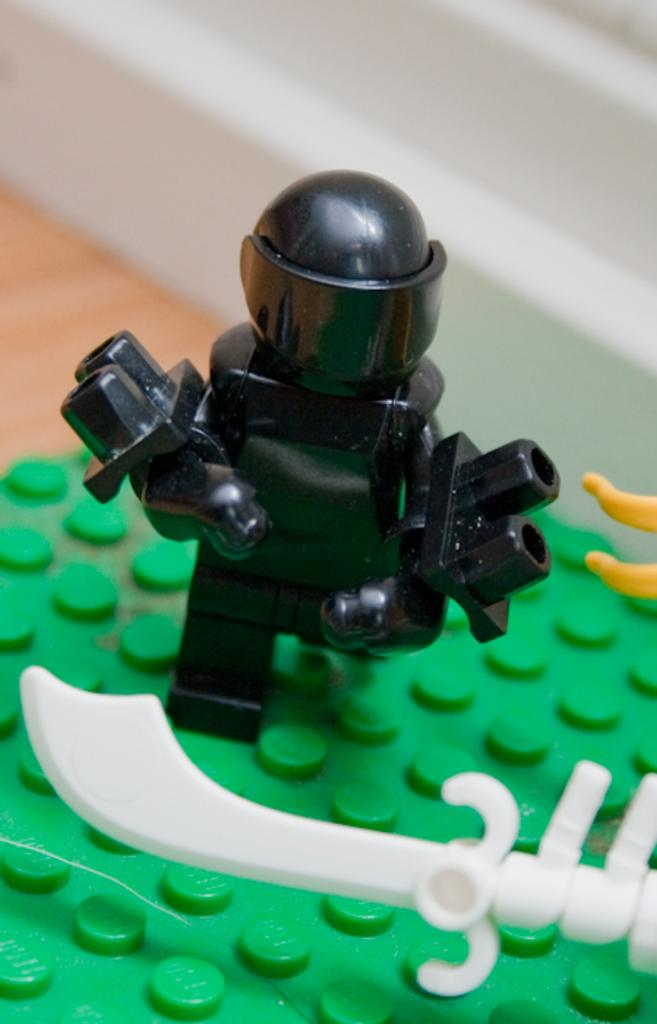What objects can be seen in the image? There are toys in the image. Can you describe the background of the image? The background of the image is blurry. What day of the week is it in the image? The day of the week cannot be determined from the image, as it does not contain any information about the date or time. 